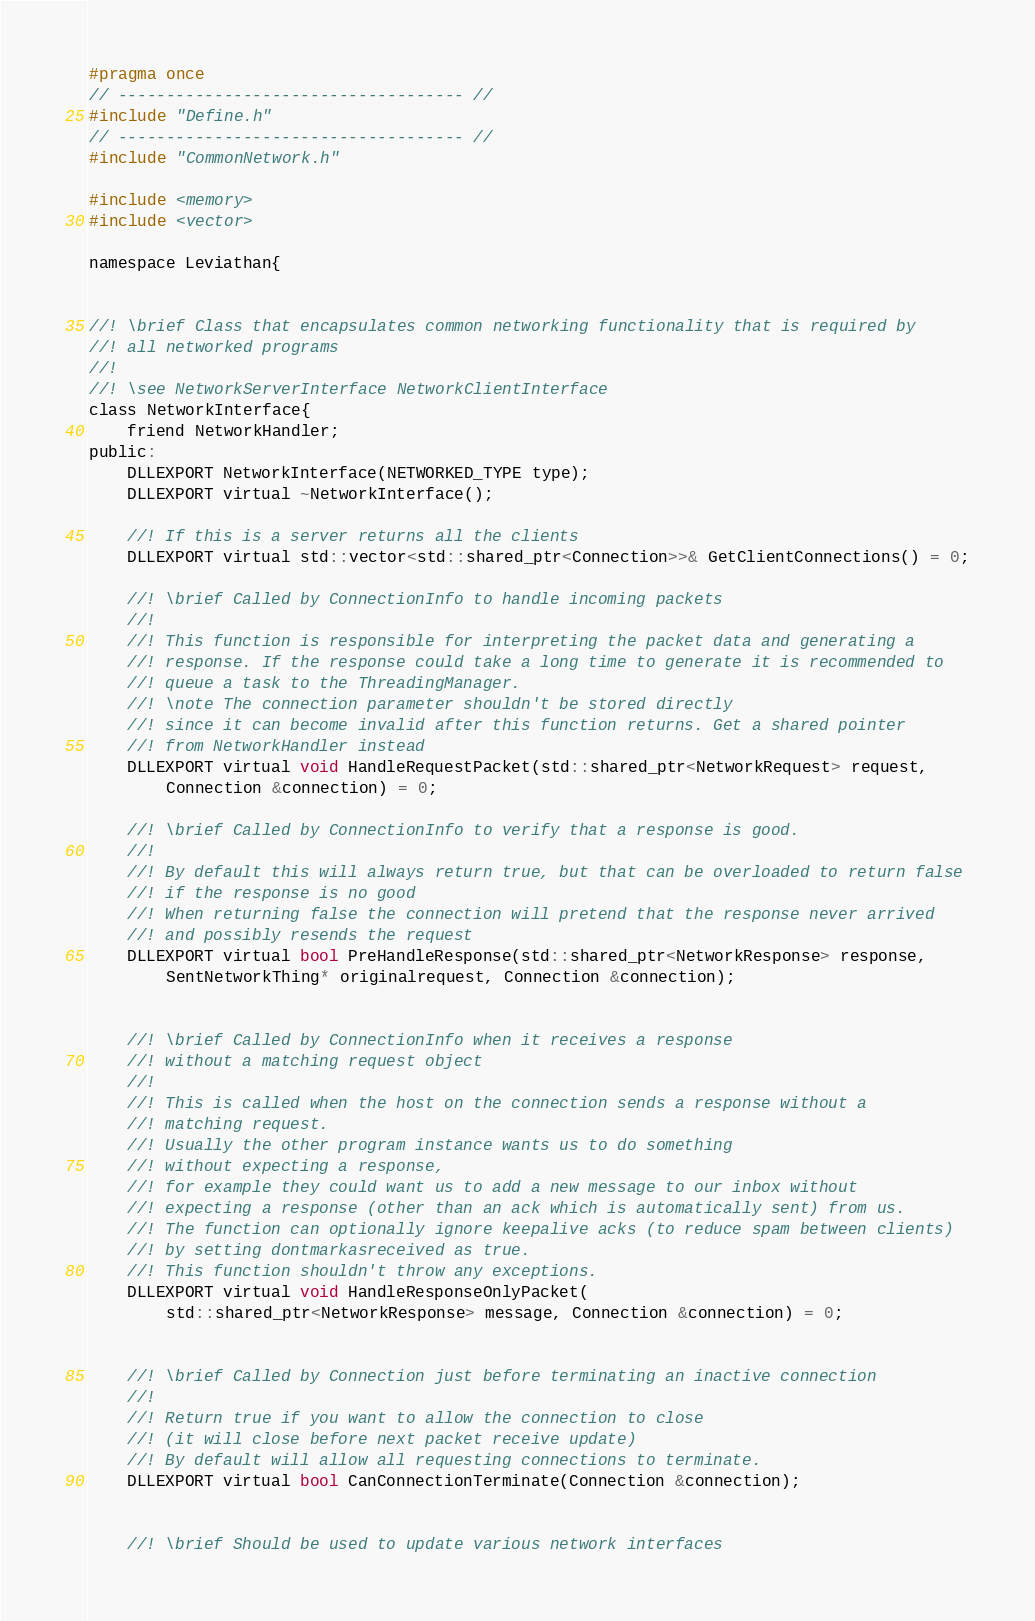<code> <loc_0><loc_0><loc_500><loc_500><_C_>#pragma once
// ------------------------------------ //
#include "Define.h"
// ------------------------------------ //
#include "CommonNetwork.h"

#include <memory>
#include <vector>

namespace Leviathan{


//! \brief Class that encapsulates common networking functionality that is required by
//! all networked programs
//!
//! \see NetworkServerInterface NetworkClientInterface
class NetworkInterface{
    friend NetworkHandler;
public:
    DLLEXPORT NetworkInterface(NETWORKED_TYPE type);
    DLLEXPORT virtual ~NetworkInterface();

    //! If this is a server returns all the clients
    DLLEXPORT virtual std::vector<std::shared_ptr<Connection>>& GetClientConnections() = 0;

    //! \brief Called by ConnectionInfo to handle incoming packets
    //!
    //! This function is responsible for interpreting the packet data and generating a
    //! response. If the response could take a long time to generate it is recommended to
    //! queue a task to the ThreadingManager. 
    //! \note The connection parameter shouldn't be stored directly
    //! since it can become invalid after this function returns. Get a shared pointer
    //! from NetworkHandler instead
    DLLEXPORT virtual void HandleRequestPacket(std::shared_ptr<NetworkRequest> request,
        Connection &connection) = 0;
        
    //! \brief Called by ConnectionInfo to verify that a response is good.
    //!
    //! By default this will always return true, but that can be overloaded to return false
    //! if the response is no good
    //! When returning false the connection will pretend that the response never arrived
    //! and possibly resends the request
    DLLEXPORT virtual bool PreHandleResponse(std::shared_ptr<NetworkResponse> response,
        SentNetworkThing* originalrequest, Connection &connection);

        
    //! \brief Called by ConnectionInfo when it receives a response
    //! without a matching request object
    //!
    //! This is called when the host on the connection sends a response without a
    //! matching request.
    //! Usually the other program instance wants us to do something
    //! without expecting a response,
    //! for example they could want us to add a new message to our inbox without
    //! expecting a response (other than an ack which is automatically sent) from us. 
    //! The function can optionally ignore keepalive acks (to reduce spam between clients)
    //! by setting dontmarkasreceived as true.
    //! This function shouldn't throw any exceptions.
    DLLEXPORT virtual void HandleResponseOnlyPacket(
        std::shared_ptr<NetworkResponse> message, Connection &connection) = 0;

        
    //! \brief Called by Connection just before terminating an inactive connection
    //!
    //! Return true if you want to allow the connection to close
    //! (it will close before next packet receive update)
    //! By default will allow all requesting connections to terminate.
    DLLEXPORT virtual bool CanConnectionTerminate(Connection &connection);


    //! \brief Should be used to update various network interfaces</code> 